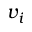<formula> <loc_0><loc_0><loc_500><loc_500>v _ { i }</formula> 